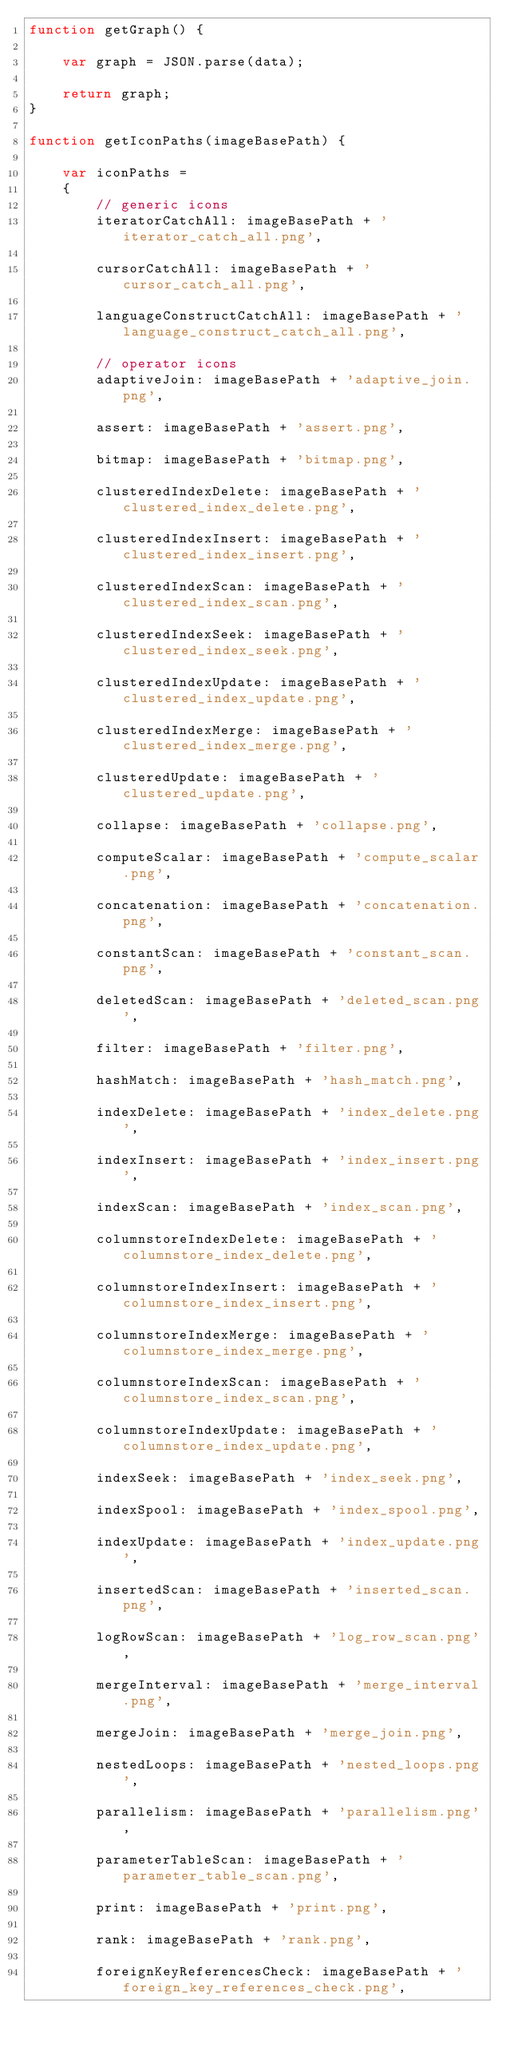Convert code to text. <code><loc_0><loc_0><loc_500><loc_500><_JavaScript_>function getGraph() {

	var graph = JSON.parse(data);

	return graph;
}

function getIconPaths(imageBasePath) {

	var iconPaths =
	{
		// generic icons
		iteratorCatchAll: imageBasePath + 'iterator_catch_all.png',

		cursorCatchAll: imageBasePath + 'cursor_catch_all.png',

		languageConstructCatchAll: imageBasePath + 'language_construct_catch_all.png',

		// operator icons
		adaptiveJoin: imageBasePath + 'adaptive_join.png',

		assert: imageBasePath + 'assert.png',

		bitmap: imageBasePath + 'bitmap.png',

		clusteredIndexDelete: imageBasePath + 'clustered_index_delete.png',

		clusteredIndexInsert: imageBasePath + 'clustered_index_insert.png',

		clusteredIndexScan: imageBasePath + 'clustered_index_scan.png',

		clusteredIndexSeek: imageBasePath + 'clustered_index_seek.png',

		clusteredIndexUpdate: imageBasePath + 'clustered_index_update.png',

		clusteredIndexMerge: imageBasePath + 'clustered_index_merge.png',

		clusteredUpdate: imageBasePath + 'clustered_update.png',

		collapse: imageBasePath + 'collapse.png',

		computeScalar: imageBasePath + 'compute_scalar.png',

		concatenation: imageBasePath + 'concatenation.png',

		constantScan: imageBasePath + 'constant_scan.png',

		deletedScan: imageBasePath + 'deleted_scan.png',

		filter: imageBasePath + 'filter.png',

		hashMatch: imageBasePath + 'hash_match.png',

		indexDelete: imageBasePath + 'index_delete.png',

		indexInsert: imageBasePath + 'index_insert.png',

		indexScan: imageBasePath + 'index_scan.png',

		columnstoreIndexDelete: imageBasePath + 'columnstore_index_delete.png',

		columnstoreIndexInsert: imageBasePath + 'columnstore_index_insert.png',

		columnstoreIndexMerge: imageBasePath + 'columnstore_index_merge.png',

		columnstoreIndexScan: imageBasePath + 'columnstore_index_scan.png',

		columnstoreIndexUpdate: imageBasePath + 'columnstore_index_update.png',

		indexSeek: imageBasePath + 'index_seek.png',

		indexSpool: imageBasePath + 'index_spool.png',

		indexUpdate: imageBasePath + 'index_update.png',

		insertedScan: imageBasePath + 'inserted_scan.png',

		logRowScan: imageBasePath + 'log_row_scan.png',

		mergeInterval: imageBasePath + 'merge_interval.png',

		mergeJoin: imageBasePath + 'merge_join.png',

		nestedLoops: imageBasePath + 'nested_loops.png',

		parallelism: imageBasePath + 'parallelism.png',

		parameterTableScan: imageBasePath + 'parameter_table_scan.png',

		print: imageBasePath + 'print.png',

		rank: imageBasePath + 'rank.png',

		foreignKeyReferencesCheck: imageBasePath + 'foreign_key_references_check.png',
</code> 